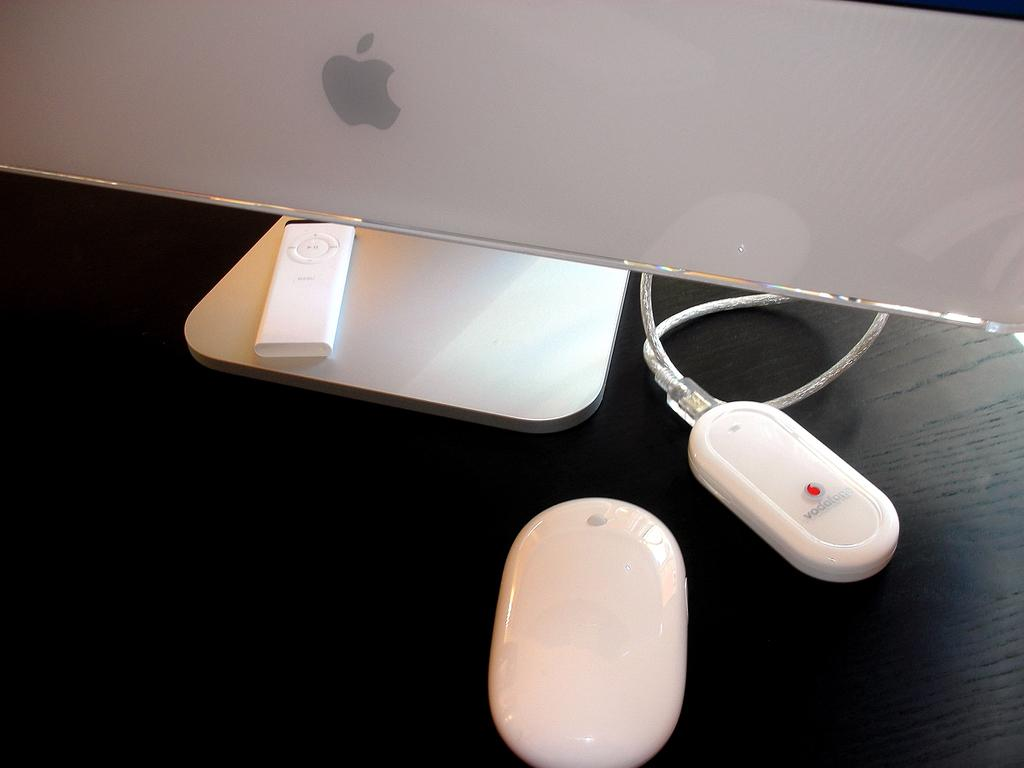What type of electronic device is visible in the image? There is a monitor in the image. What is used for input with the monitor? There is a mouse in the image. What type of portable music player is present in the image? There is an iPod in the image. What type of adapter is connected to a wire in the image? There is a dongle connected to a wire in the image. What type of group behavior can be observed in the image? There is no group behavior present in the image; it features individual electronic devices. What type of poison is being used in the image? There is no poison present in the image; it features electronic devices and accessories. 